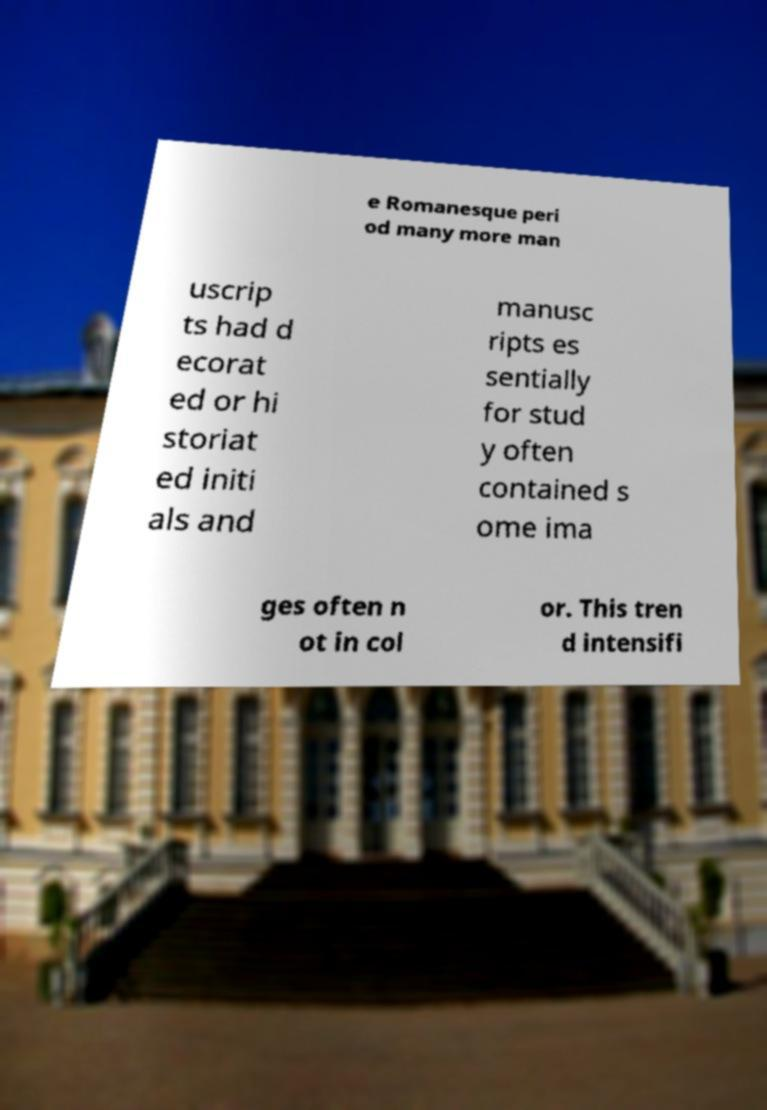Can you read and provide the text displayed in the image?This photo seems to have some interesting text. Can you extract and type it out for me? e Romanesque peri od many more man uscrip ts had d ecorat ed or hi storiat ed initi als and manusc ripts es sentially for stud y often contained s ome ima ges often n ot in col or. This tren d intensifi 